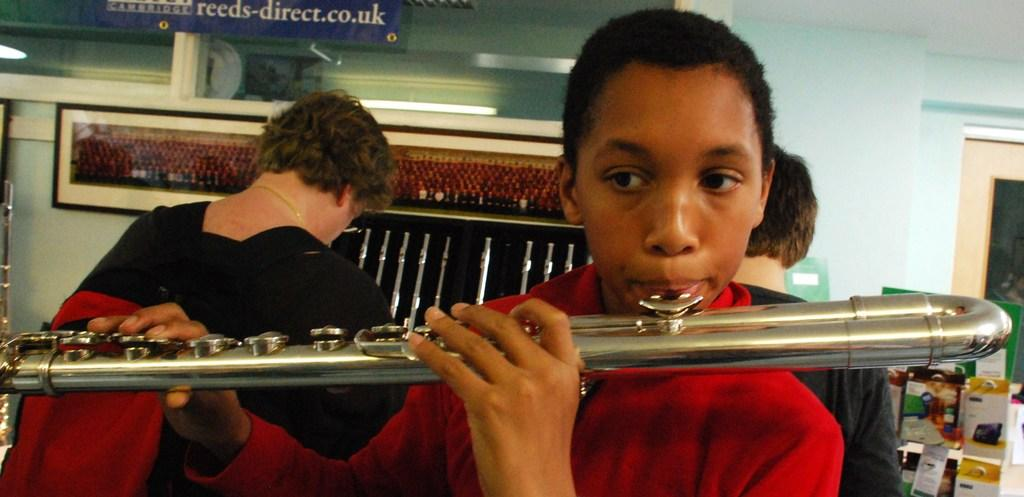What is the main subject of the image? The main subject of the image is a boy. What is the boy holding in the image? The boy is holding a musical instrument. How is the boy interacting with the musical instrument? The musical instrument is near the boy's mouth, suggesting that he might be playing it. What can be seen in the background of the image? There are persons standing in the background, as well as name boards and walls. Can you tell me how many copies of the copper zoo animals are visible in the image? There are no zoo animals, copper or otherwise, visible in the image. The main subject is a boy holding a musical instrument, and the background features persons, name boards, and walls. 